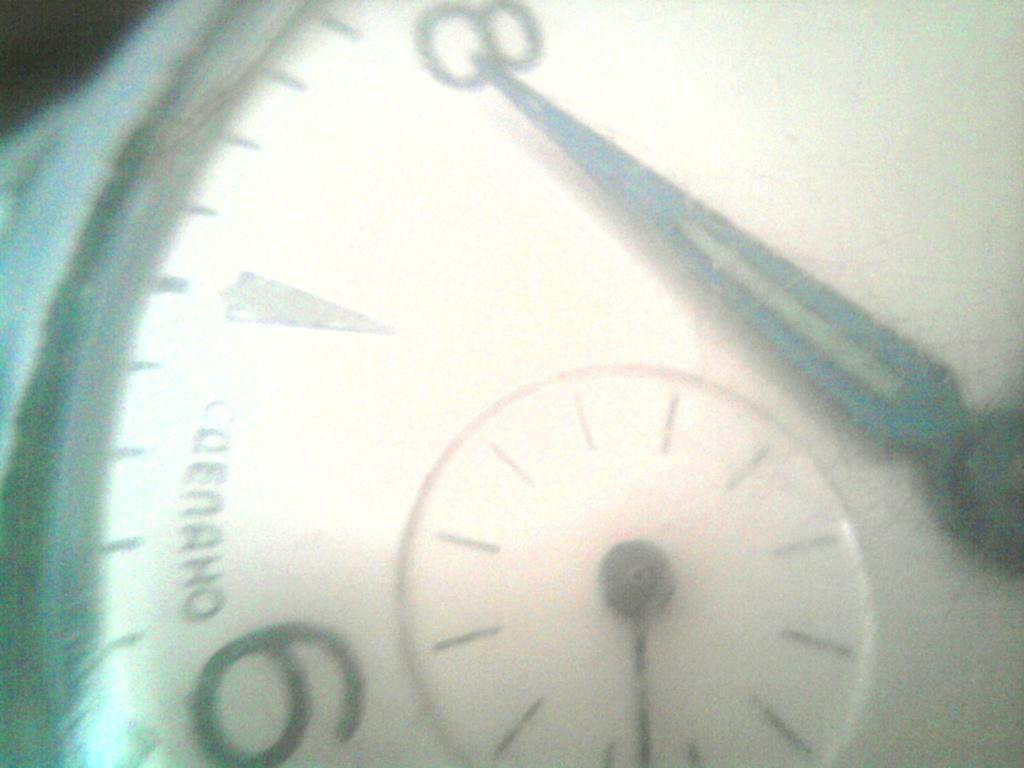Provide a one-sentence caption for the provided image. Face of a watch which says the word "Codeaho" on it. 